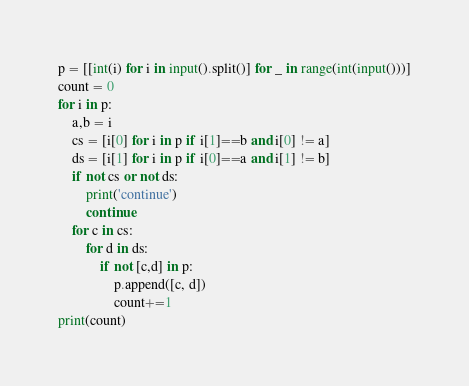<code> <loc_0><loc_0><loc_500><loc_500><_Python_>
p = [[int(i) for i in input().split()] for _ in range(int(input()))]
count = 0
for i in p:
    a,b = i
    cs = [i[0] for i in p if i[1]==b and i[0] != a]
    ds = [i[1] for i in p if i[0]==a and i[1] != b]
    if not cs or not ds:
        print('continue')
        continue
    for c in cs:
        for d in ds:
            if not [c,d] in p:
                p.append([c, d])
                count+=1
print(count)</code> 